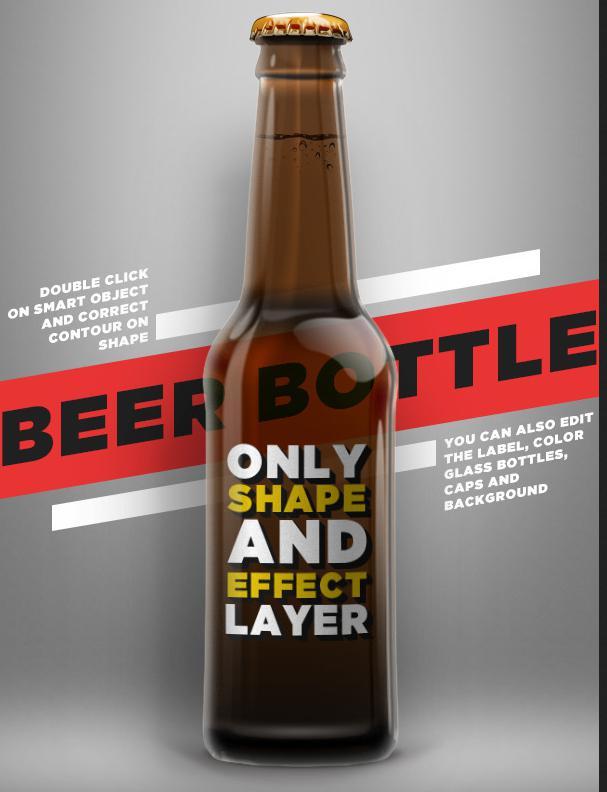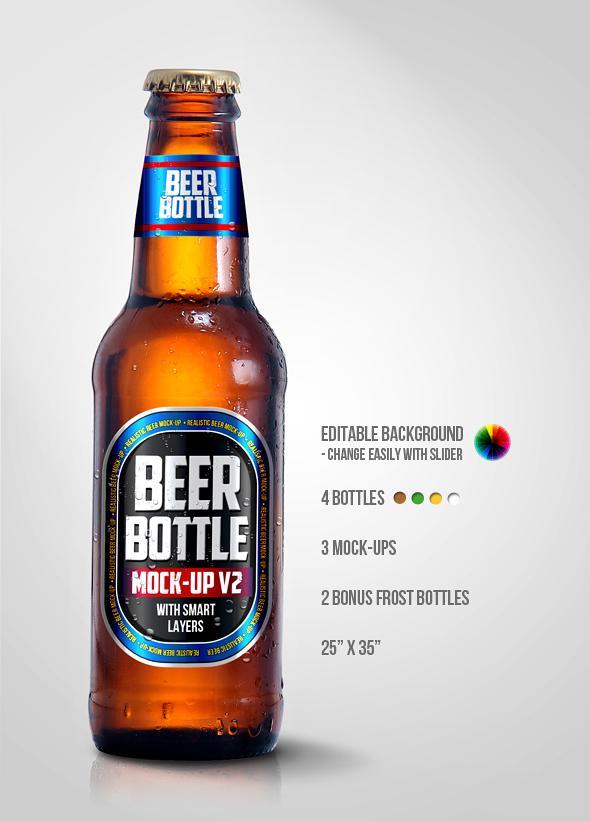The first image is the image on the left, the second image is the image on the right. For the images shown, is this caption "There are no less than three beer bottles" true? Answer yes or no. No. The first image is the image on the left, the second image is the image on the right. Considering the images on both sides, is "there are at least two bottles in the image on the left" valid? Answer yes or no. No. 